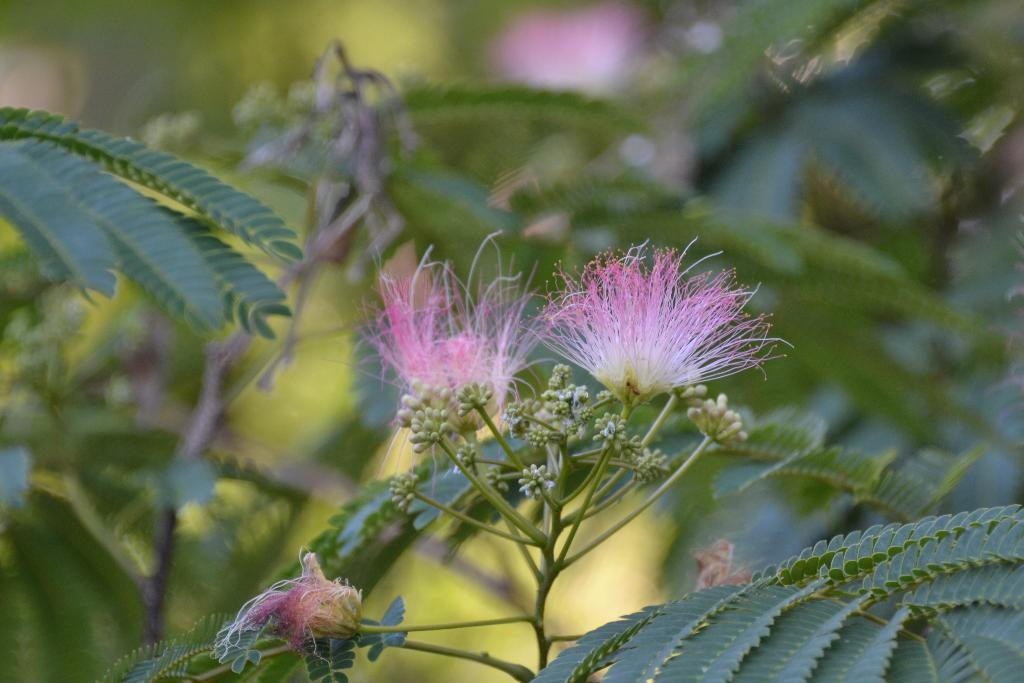What type of plant can be seen in the image? There is a tree in the image. Are there any additional features related to the tree? Yes, there are flowers on or near the tree. Where is the throne located in the image? There is no throne present in the image. What type of ear is visible on the tree in the image? There are no ears visible on the tree in the image; it is a tree with flowers. 